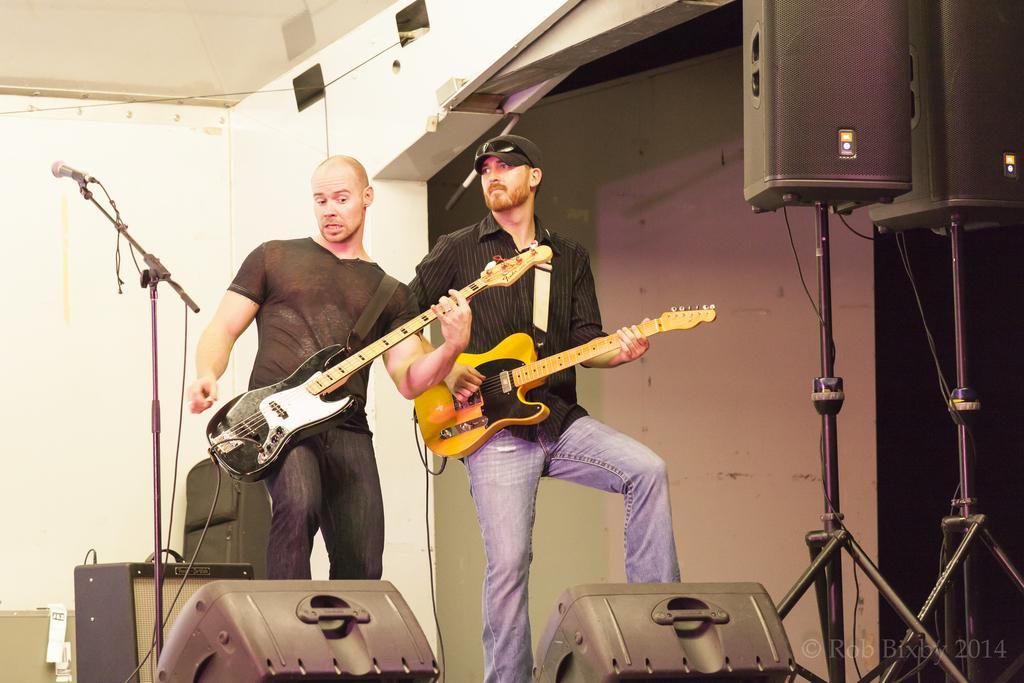Can you describe this image briefly? In the picture there are two persons playing guitar there is a microphone near to them there are some sound boxes near them there are some lights near to them there are some cables near to them. 